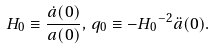Convert formula to latex. <formula><loc_0><loc_0><loc_500><loc_500>H _ { 0 } \equiv \frac { \dot { a } ( 0 ) } { a ( 0 ) } , \, q _ { 0 } \equiv - { H _ { 0 } } ^ { - 2 } \ddot { a } ( 0 ) .</formula> 